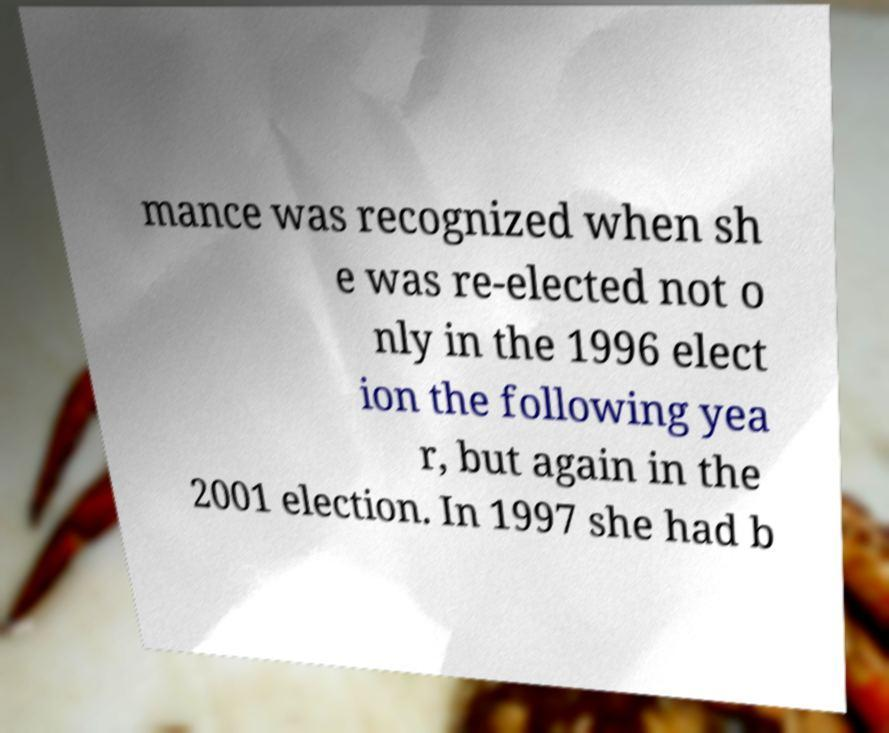Please read and relay the text visible in this image. What does it say? mance was recognized when sh e was re-elected not o nly in the 1996 elect ion the following yea r, but again in the 2001 election. In 1997 she had b 